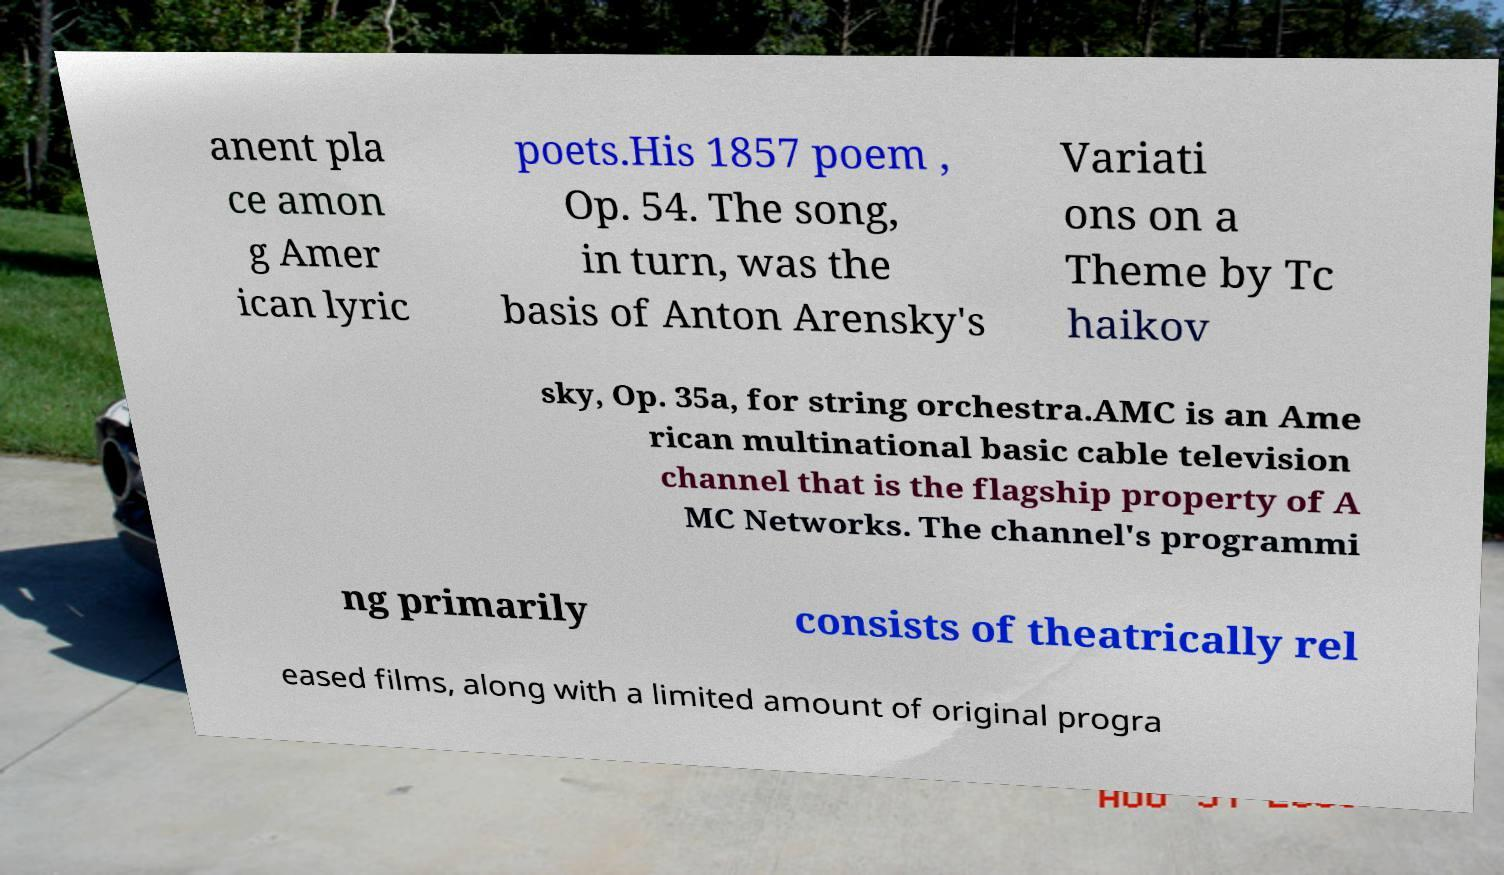Can you read and provide the text displayed in the image?This photo seems to have some interesting text. Can you extract and type it out for me? anent pla ce amon g Amer ican lyric poets.His 1857 poem , Op. 54. The song, in turn, was the basis of Anton Arensky's Variati ons on a Theme by Tc haikov sky, Op. 35a, for string orchestra.AMC is an Ame rican multinational basic cable television channel that is the flagship property of A MC Networks. The channel's programmi ng primarily consists of theatrically rel eased films, along with a limited amount of original progra 